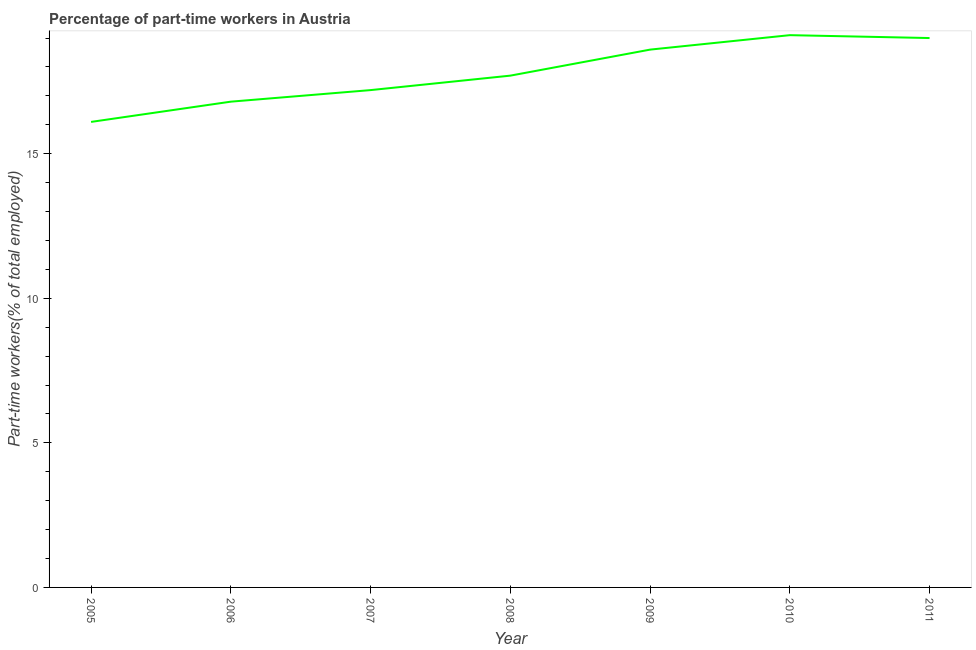Across all years, what is the maximum percentage of part-time workers?
Your response must be concise. 19.1. Across all years, what is the minimum percentage of part-time workers?
Your answer should be compact. 16.1. In which year was the percentage of part-time workers minimum?
Provide a succinct answer. 2005. What is the sum of the percentage of part-time workers?
Provide a succinct answer. 124.5. What is the difference between the percentage of part-time workers in 2006 and 2009?
Keep it short and to the point. -1.8. What is the average percentage of part-time workers per year?
Make the answer very short. 17.79. What is the median percentage of part-time workers?
Your answer should be very brief. 17.7. In how many years, is the percentage of part-time workers greater than 2 %?
Your answer should be very brief. 7. Do a majority of the years between 2009 and 2007 (inclusive) have percentage of part-time workers greater than 18 %?
Offer a terse response. No. What is the ratio of the percentage of part-time workers in 2005 to that in 2009?
Give a very brief answer. 0.87. Is the difference between the percentage of part-time workers in 2008 and 2010 greater than the difference between any two years?
Give a very brief answer. No. What is the difference between the highest and the second highest percentage of part-time workers?
Make the answer very short. 0.1. Is the sum of the percentage of part-time workers in 2007 and 2008 greater than the maximum percentage of part-time workers across all years?
Your answer should be very brief. Yes. In how many years, is the percentage of part-time workers greater than the average percentage of part-time workers taken over all years?
Offer a very short reply. 3. What is the title of the graph?
Give a very brief answer. Percentage of part-time workers in Austria. What is the label or title of the Y-axis?
Offer a terse response. Part-time workers(% of total employed). What is the Part-time workers(% of total employed) in 2005?
Your answer should be compact. 16.1. What is the Part-time workers(% of total employed) in 2006?
Provide a short and direct response. 16.8. What is the Part-time workers(% of total employed) of 2007?
Provide a short and direct response. 17.2. What is the Part-time workers(% of total employed) in 2008?
Make the answer very short. 17.7. What is the Part-time workers(% of total employed) of 2009?
Keep it short and to the point. 18.6. What is the Part-time workers(% of total employed) of 2010?
Your answer should be very brief. 19.1. What is the Part-time workers(% of total employed) of 2011?
Offer a very short reply. 19. What is the difference between the Part-time workers(% of total employed) in 2005 and 2007?
Your response must be concise. -1.1. What is the difference between the Part-time workers(% of total employed) in 2005 and 2008?
Ensure brevity in your answer.  -1.6. What is the difference between the Part-time workers(% of total employed) in 2005 and 2010?
Keep it short and to the point. -3. What is the difference between the Part-time workers(% of total employed) in 2006 and 2009?
Offer a very short reply. -1.8. What is the difference between the Part-time workers(% of total employed) in 2006 and 2010?
Offer a very short reply. -2.3. What is the difference between the Part-time workers(% of total employed) in 2007 and 2008?
Provide a short and direct response. -0.5. What is the difference between the Part-time workers(% of total employed) in 2007 and 2011?
Your response must be concise. -1.8. What is the difference between the Part-time workers(% of total employed) in 2009 and 2010?
Your answer should be compact. -0.5. What is the difference between the Part-time workers(% of total employed) in 2010 and 2011?
Give a very brief answer. 0.1. What is the ratio of the Part-time workers(% of total employed) in 2005 to that in 2006?
Provide a succinct answer. 0.96. What is the ratio of the Part-time workers(% of total employed) in 2005 to that in 2007?
Make the answer very short. 0.94. What is the ratio of the Part-time workers(% of total employed) in 2005 to that in 2008?
Keep it short and to the point. 0.91. What is the ratio of the Part-time workers(% of total employed) in 2005 to that in 2009?
Your response must be concise. 0.87. What is the ratio of the Part-time workers(% of total employed) in 2005 to that in 2010?
Keep it short and to the point. 0.84. What is the ratio of the Part-time workers(% of total employed) in 2005 to that in 2011?
Keep it short and to the point. 0.85. What is the ratio of the Part-time workers(% of total employed) in 2006 to that in 2007?
Make the answer very short. 0.98. What is the ratio of the Part-time workers(% of total employed) in 2006 to that in 2008?
Your answer should be very brief. 0.95. What is the ratio of the Part-time workers(% of total employed) in 2006 to that in 2009?
Your response must be concise. 0.9. What is the ratio of the Part-time workers(% of total employed) in 2006 to that in 2010?
Give a very brief answer. 0.88. What is the ratio of the Part-time workers(% of total employed) in 2006 to that in 2011?
Your answer should be very brief. 0.88. What is the ratio of the Part-time workers(% of total employed) in 2007 to that in 2009?
Offer a very short reply. 0.93. What is the ratio of the Part-time workers(% of total employed) in 2007 to that in 2010?
Provide a short and direct response. 0.9. What is the ratio of the Part-time workers(% of total employed) in 2007 to that in 2011?
Make the answer very short. 0.91. What is the ratio of the Part-time workers(% of total employed) in 2008 to that in 2009?
Offer a very short reply. 0.95. What is the ratio of the Part-time workers(% of total employed) in 2008 to that in 2010?
Ensure brevity in your answer.  0.93. What is the ratio of the Part-time workers(% of total employed) in 2008 to that in 2011?
Offer a terse response. 0.93. What is the ratio of the Part-time workers(% of total employed) in 2009 to that in 2010?
Give a very brief answer. 0.97. 